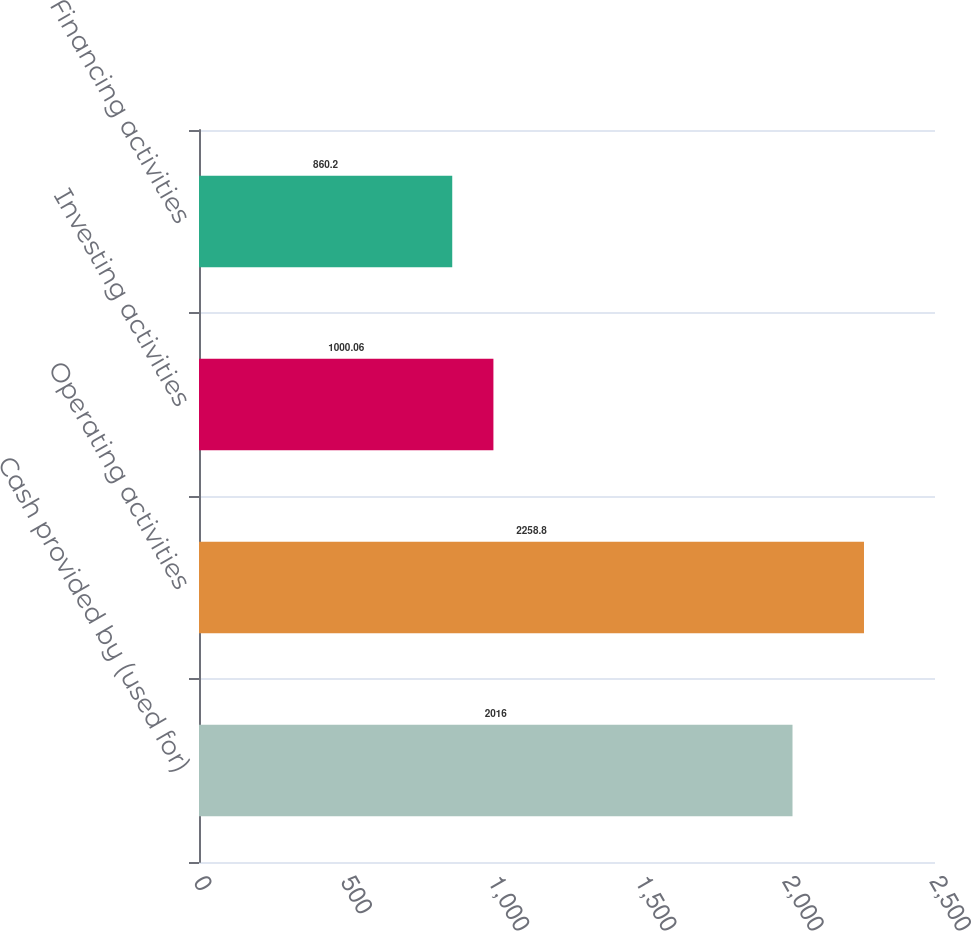Convert chart to OTSL. <chart><loc_0><loc_0><loc_500><loc_500><bar_chart><fcel>Cash provided by (used for)<fcel>Operating activities<fcel>Investing activities<fcel>Financing activities<nl><fcel>2016<fcel>2258.8<fcel>1000.06<fcel>860.2<nl></chart> 